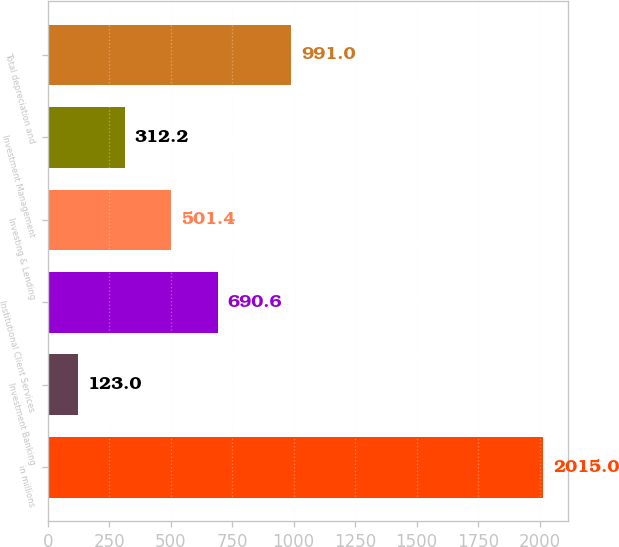<chart> <loc_0><loc_0><loc_500><loc_500><bar_chart><fcel>in millions<fcel>Investment Banking<fcel>Institutional Client Services<fcel>Investing & Lending<fcel>Investment Management<fcel>Total depreciation and<nl><fcel>2015<fcel>123<fcel>690.6<fcel>501.4<fcel>312.2<fcel>991<nl></chart> 